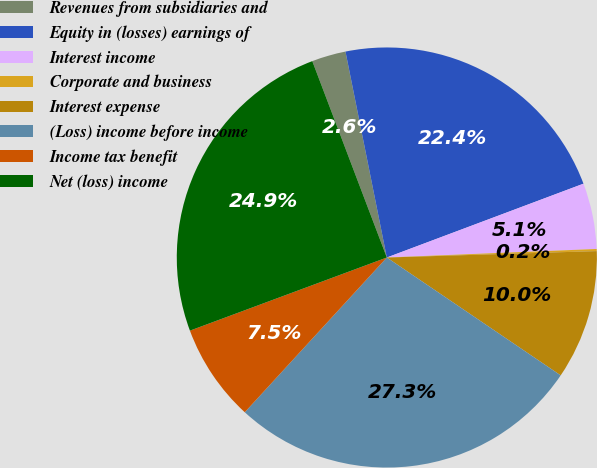Convert chart to OTSL. <chart><loc_0><loc_0><loc_500><loc_500><pie_chart><fcel>Revenues from subsidiaries and<fcel>Equity in (losses) earnings of<fcel>Interest income<fcel>Corporate and business<fcel>Interest expense<fcel>(Loss) income before income<fcel>Income tax benefit<fcel>Net (loss) income<nl><fcel>2.62%<fcel>22.44%<fcel>5.07%<fcel>0.16%<fcel>9.97%<fcel>27.34%<fcel>7.52%<fcel>24.89%<nl></chart> 